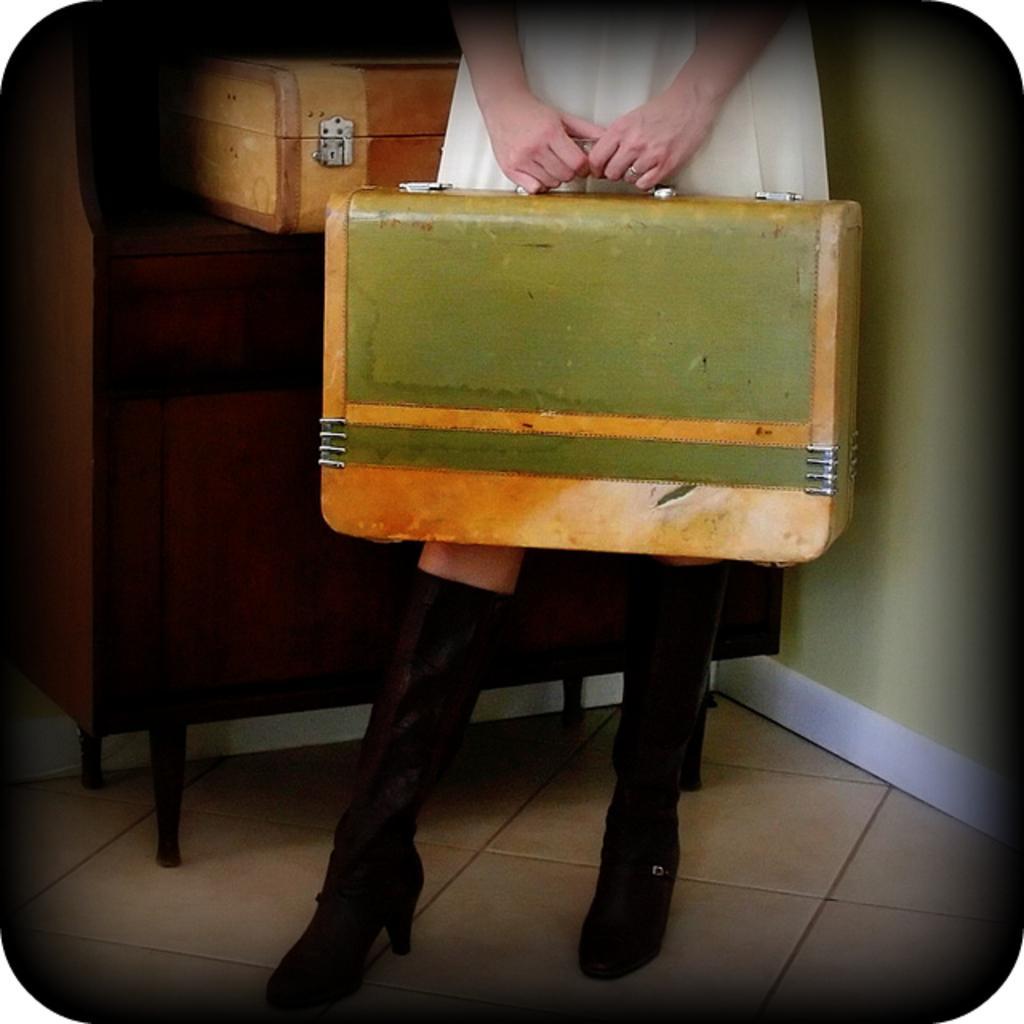Describe this image in one or two sentences. In this image, a human is holding a box and there is a another box behind her. That is placed on wooden cupboard. We can see bottom floor and right side we can see a wall. 